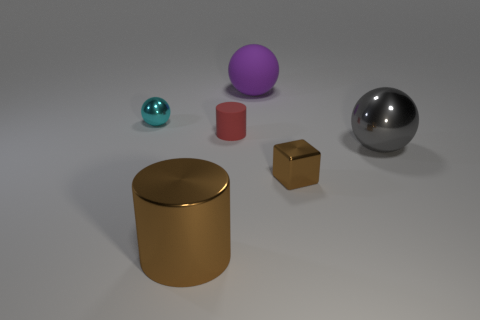Add 2 small brown things. How many objects exist? 8 Subtract all cubes. How many objects are left? 5 Add 3 small cyan cylinders. How many small cyan cylinders exist? 3 Subtract 0 blue cubes. How many objects are left? 6 Subtract all red objects. Subtract all small things. How many objects are left? 2 Add 6 brown cubes. How many brown cubes are left? 7 